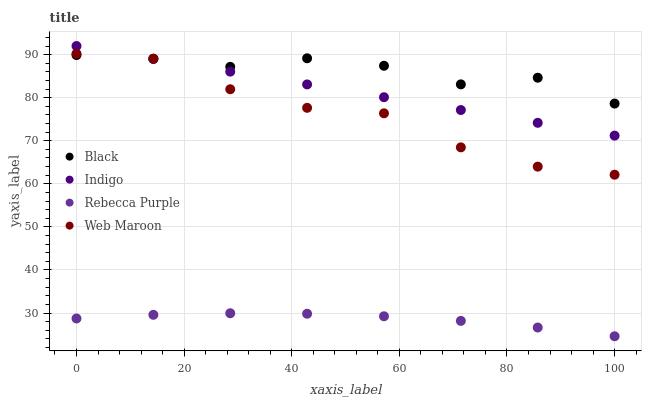Does Rebecca Purple have the minimum area under the curve?
Answer yes or no. Yes. Does Black have the maximum area under the curve?
Answer yes or no. Yes. Does Black have the minimum area under the curve?
Answer yes or no. No. Does Rebecca Purple have the maximum area under the curve?
Answer yes or no. No. Is Indigo the smoothest?
Answer yes or no. Yes. Is Black the roughest?
Answer yes or no. Yes. Is Rebecca Purple the smoothest?
Answer yes or no. No. Is Rebecca Purple the roughest?
Answer yes or no. No. Does Rebecca Purple have the lowest value?
Answer yes or no. Yes. Does Black have the lowest value?
Answer yes or no. No. Does Indigo have the highest value?
Answer yes or no. Yes. Does Black have the highest value?
Answer yes or no. No. Is Rebecca Purple less than Indigo?
Answer yes or no. Yes. Is Black greater than Rebecca Purple?
Answer yes or no. Yes. Does Black intersect Indigo?
Answer yes or no. Yes. Is Black less than Indigo?
Answer yes or no. No. Is Black greater than Indigo?
Answer yes or no. No. Does Rebecca Purple intersect Indigo?
Answer yes or no. No. 